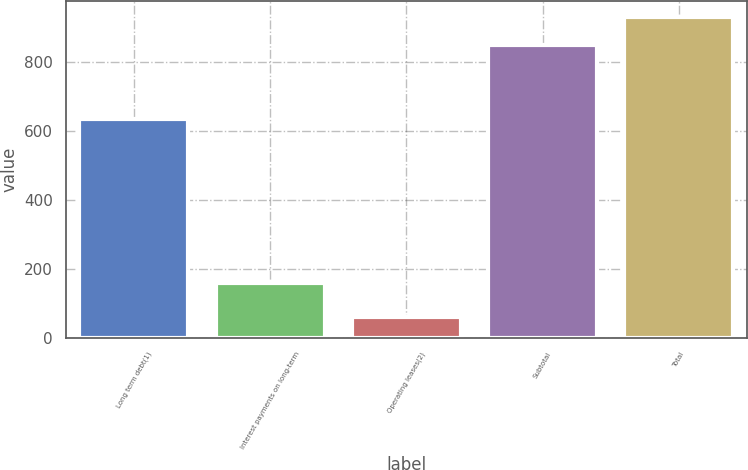Convert chart. <chart><loc_0><loc_0><loc_500><loc_500><bar_chart><fcel>Long term debt(1)<fcel>Interest payments on long-term<fcel>Operating leases(2)<fcel>Subtotal<fcel>Total<nl><fcel>635<fcel>158<fcel>59<fcel>852<fcel>931.3<nl></chart> 